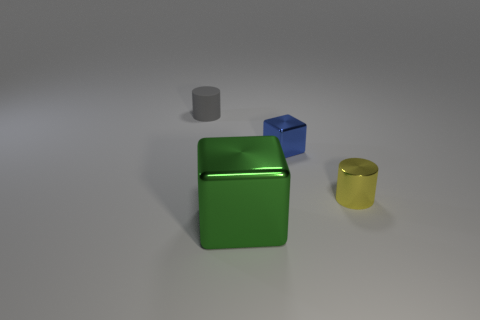What number of small gray cylinders are there? There is one small gray cylinder in the image, which can be found lying on its side between the large green cube and the blue cube. 